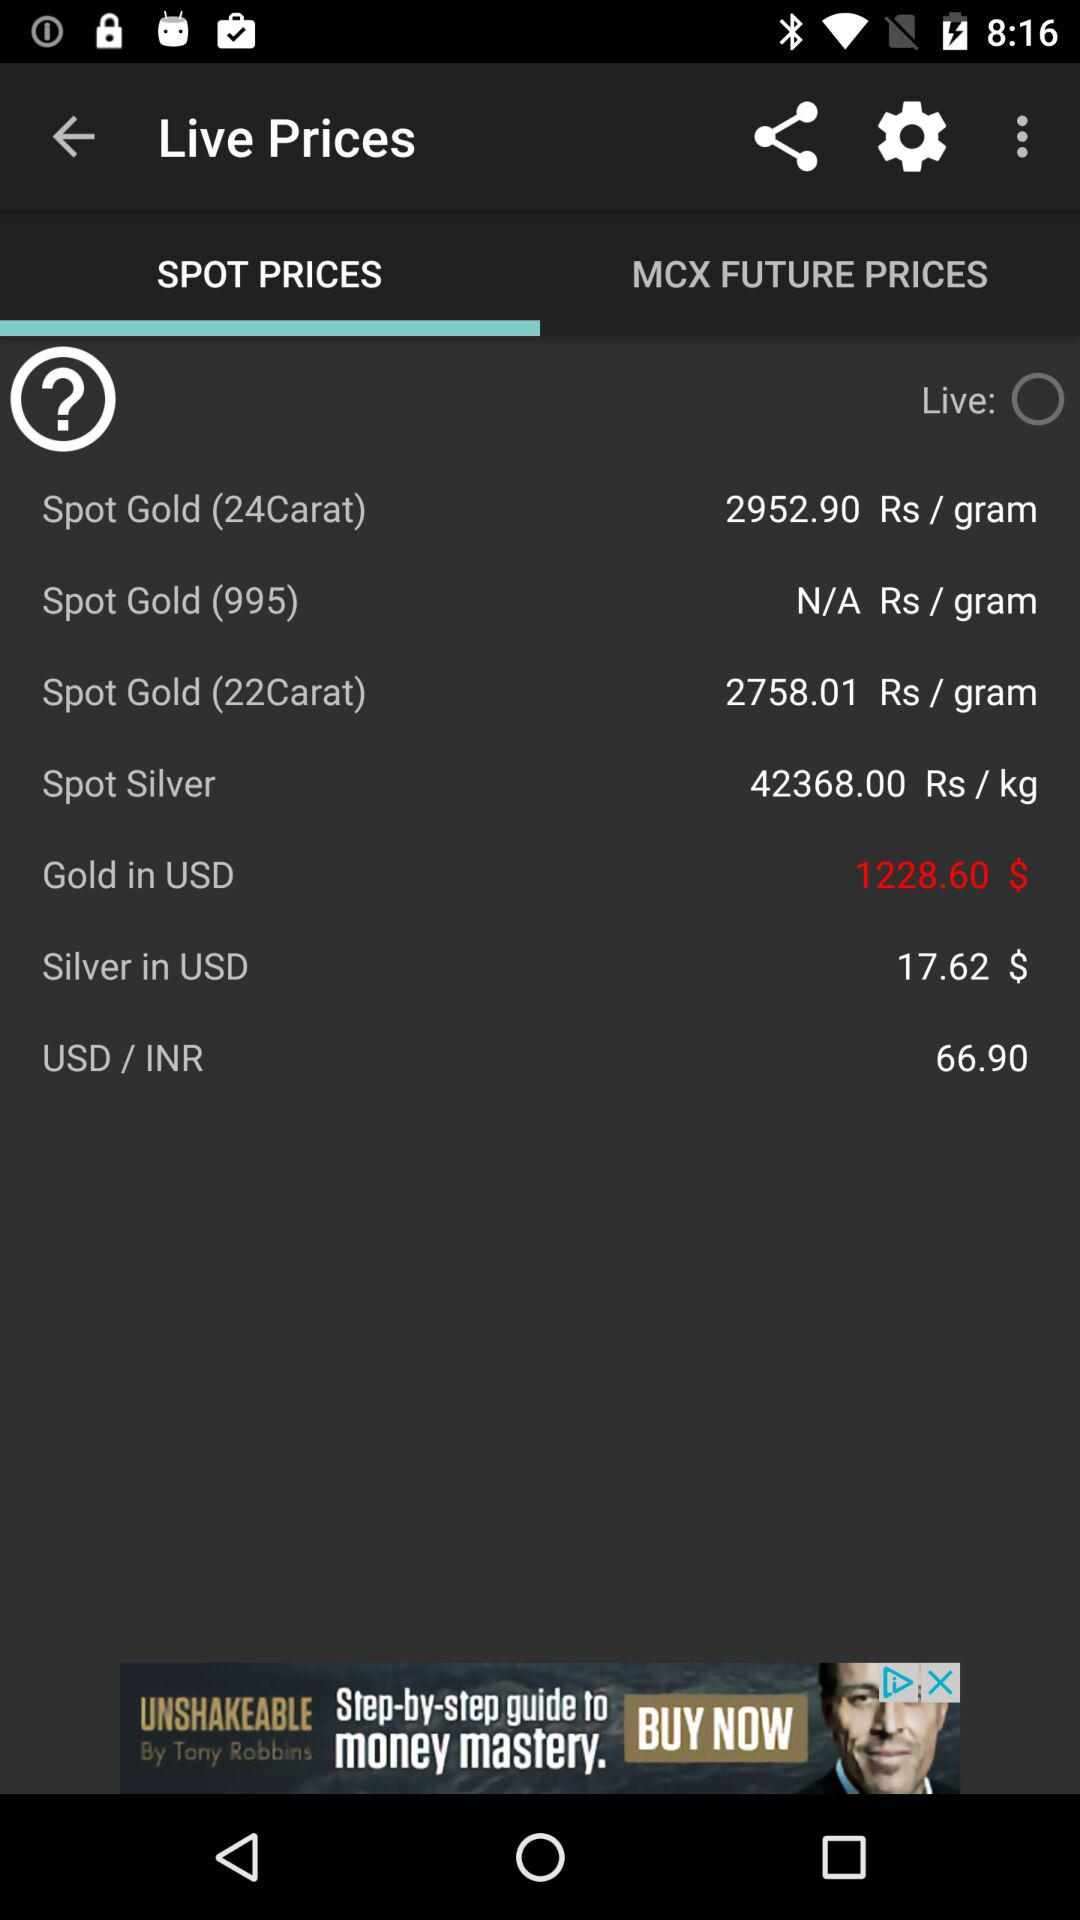How much more is the price of 24 carat gold than 22 carat gold?
Answer the question using a single word or phrase. 194.89 